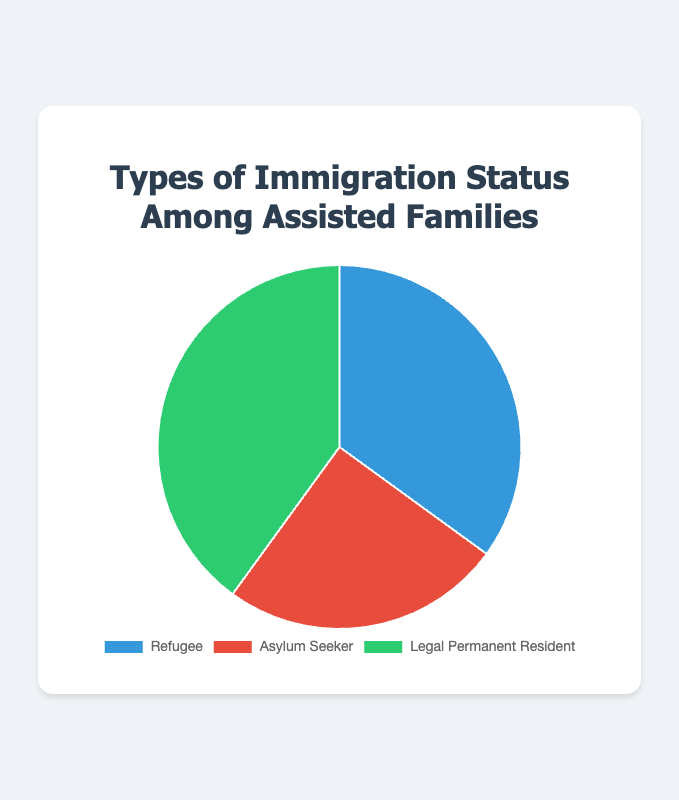What percentage of assisted families have a Legal Permanent Resident status? The slice labeled "Legal Permanent Resident" on the pie chart is 40% of the whole pie.
Answer: 40% Which immigration status has the smallest percentage among assisted families? Compare the three percentages: Refugee (35%), Asylum Seeker (25%), Legal Permanent Resident (40%). The Asylum Seeker status has the smallest percentage at 25%.
Answer: Asylum Seeker What's the combined percentage of Refugee and Asylum Seeker statuses? Add the percentages of Refugee (35%) and Asylum Seeker (25%) statuses: 35 + 25 = 60%.
Answer: 60% How much larger is the percentage of Legal Permanent Residents compared to Asylum Seekers? Subtract the percentage of Asylum Seekers (25%) from the percentage of Legal Permanent Residents (40%): 40 - 25 = 15%.
Answer: 15% Which color represents the Refugee status in the chart? The pie chart uses specific colors to represent each status. The Refugee status is represented by the blue color.
Answer: Blue Which immigration status is depicted using green in the chart? Examine the colors used in the pie chart and identify that the Legal Permanent Resident status is depicted in green.
Answer: Legal Permanent Resident How does the representation of Refugees compare visually to that of Asylum Seekers? The slice representing Refugees is larger than the slice representing Asylum Seekers. This indicates Refugees (35%) have a higher percentage than Asylum Seekers (25%).
Answer: Refugees have a higher percentage What is the difference in percentage between the largest and smallest immigration status groups? Identify the largest (Legal Permanent Resident at 40%) and the smallest (Asylum Seeker at 25%) and calculate the difference: 40 - 25 = 15%.
Answer: 15% If the total number of assisted families is 200, how many families are Legal Permanent Residents? Calculate by multiplying the percentage of Legal Permanent Residents (40%) by the total number of families (200): (40/100) * 200 = 80 families.
Answer: 80 families 